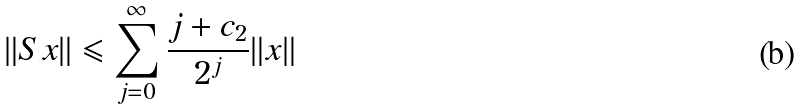Convert formula to latex. <formula><loc_0><loc_0><loc_500><loc_500>\| S x \| \leqslant \sum _ { j = 0 } ^ { \infty } \frac { j + c _ { 2 } } { 2 ^ { j } } \| x \|</formula> 